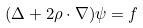<formula> <loc_0><loc_0><loc_500><loc_500>( \Delta + 2 \rho \cdot \nabla ) \psi = f</formula> 